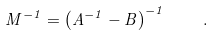Convert formula to latex. <formula><loc_0><loc_0><loc_500><loc_500>M ^ { - 1 } = \left ( A ^ { - 1 } - B \right ) ^ { - 1 } \quad .</formula> 